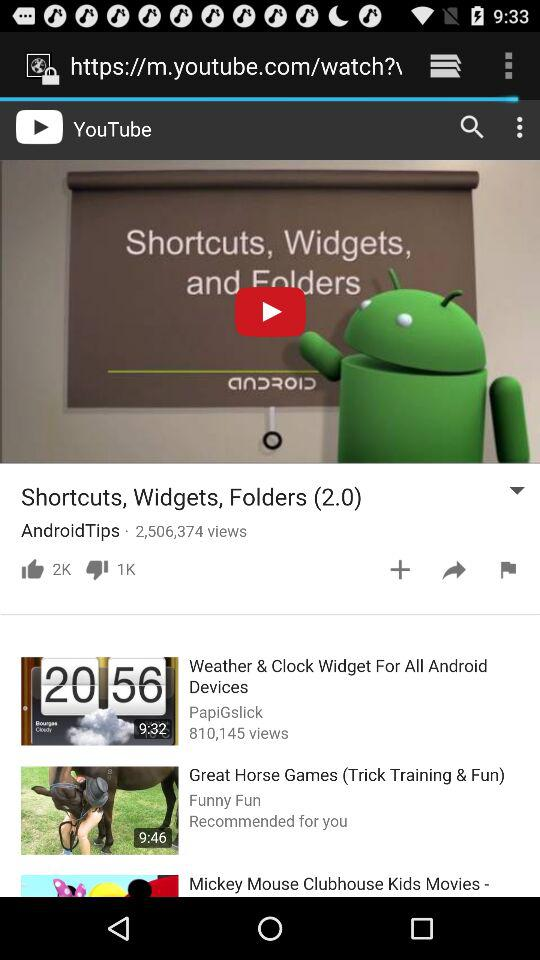How many thumbs up does the video have?
Answer the question using a single word or phrase. 2K 